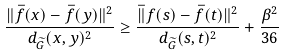<formula> <loc_0><loc_0><loc_500><loc_500>\frac { \| \bar { f } ( x ) - \bar { f } ( y ) \| ^ { 2 } } { d _ { \widetilde { G } } ( x , y ) ^ { 2 } } \geq \frac { \bar { \| } f ( s ) - \bar { f } ( t ) \| ^ { 2 } } { d _ { \widetilde { G } } ( s , t ) ^ { 2 } } + \frac { \beta ^ { 2 } } { 3 6 }</formula> 